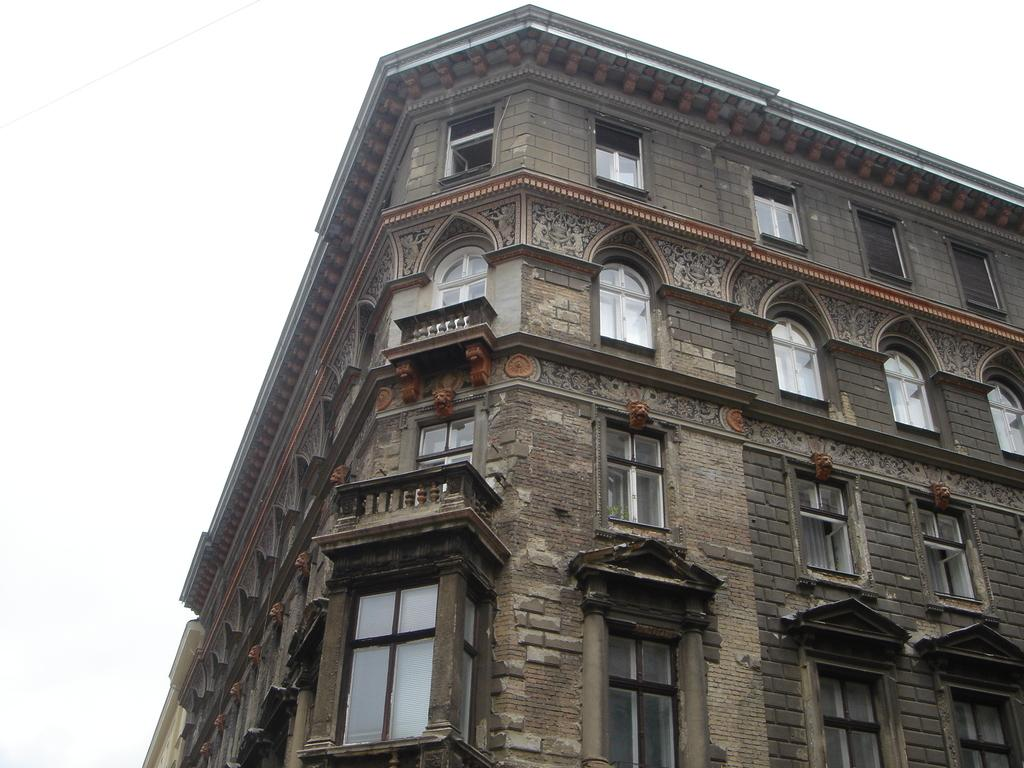What type of structure is visible in the image? There is a building in the image. What architectural features can be seen on the front of the building? There are windows and balconies in front of the building. What language is being spoken by the corn in the image? There is no corn present in the image, so it is not possible to determine what language might be spoken. 